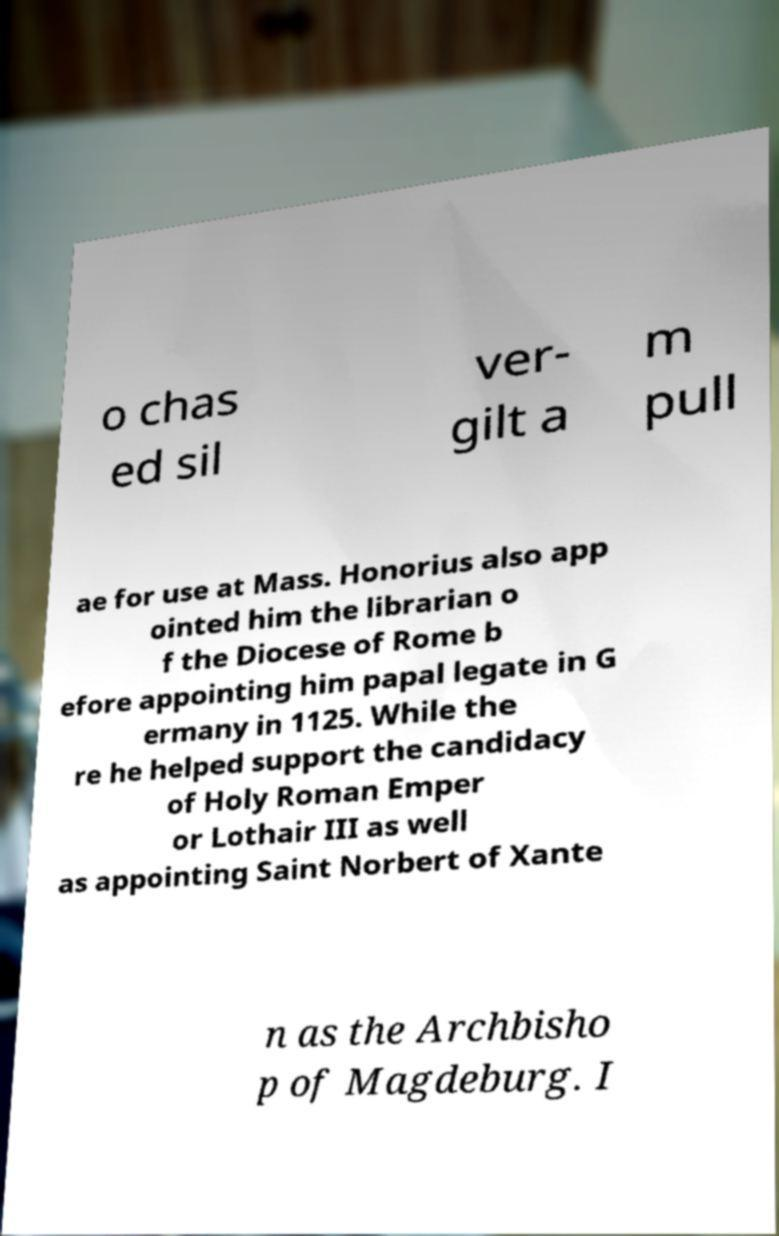Please read and relay the text visible in this image. What does it say? o chas ed sil ver- gilt a m pull ae for use at Mass. Honorius also app ointed him the librarian o f the Diocese of Rome b efore appointing him papal legate in G ermany in 1125. While the re he helped support the candidacy of Holy Roman Emper or Lothair III as well as appointing Saint Norbert of Xante n as the Archbisho p of Magdeburg. I 